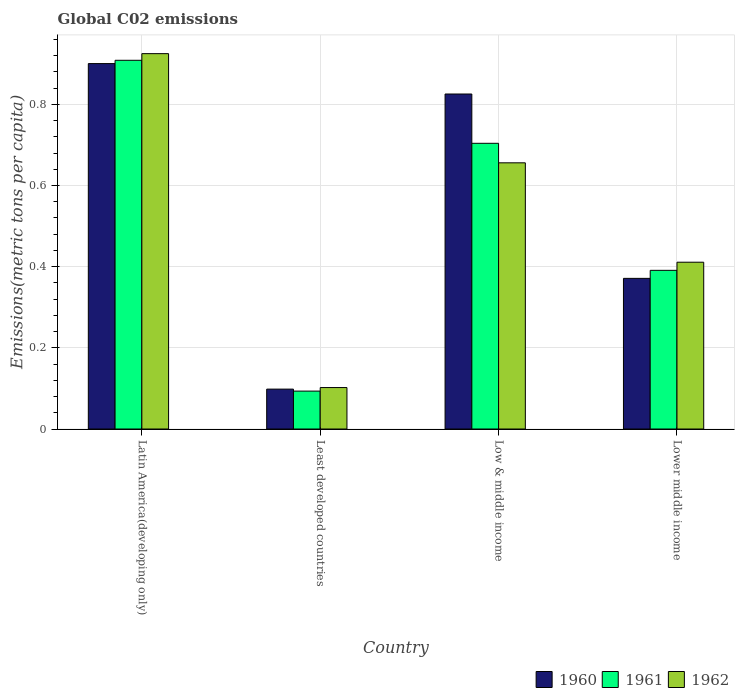How many groups of bars are there?
Your answer should be compact. 4. Are the number of bars per tick equal to the number of legend labels?
Offer a terse response. Yes. How many bars are there on the 4th tick from the left?
Your answer should be compact. 3. How many bars are there on the 2nd tick from the right?
Make the answer very short. 3. What is the label of the 3rd group of bars from the left?
Provide a short and direct response. Low & middle income. In how many cases, is the number of bars for a given country not equal to the number of legend labels?
Offer a very short reply. 0. What is the amount of CO2 emitted in in 1962 in Low & middle income?
Offer a terse response. 0.66. Across all countries, what is the maximum amount of CO2 emitted in in 1961?
Ensure brevity in your answer.  0.91. Across all countries, what is the minimum amount of CO2 emitted in in 1960?
Your answer should be compact. 0.1. In which country was the amount of CO2 emitted in in 1960 maximum?
Your answer should be compact. Latin America(developing only). In which country was the amount of CO2 emitted in in 1960 minimum?
Offer a very short reply. Least developed countries. What is the total amount of CO2 emitted in in 1961 in the graph?
Offer a very short reply. 2.1. What is the difference between the amount of CO2 emitted in in 1961 in Least developed countries and that in Low & middle income?
Your answer should be very brief. -0.61. What is the difference between the amount of CO2 emitted in in 1961 in Least developed countries and the amount of CO2 emitted in in 1960 in Lower middle income?
Offer a terse response. -0.28. What is the average amount of CO2 emitted in in 1962 per country?
Keep it short and to the point. 0.52. What is the difference between the amount of CO2 emitted in of/in 1960 and amount of CO2 emitted in of/in 1961 in Least developed countries?
Make the answer very short. 0. In how many countries, is the amount of CO2 emitted in in 1961 greater than 0.88 metric tons per capita?
Ensure brevity in your answer.  1. What is the ratio of the amount of CO2 emitted in in 1961 in Least developed countries to that in Lower middle income?
Provide a short and direct response. 0.24. Is the amount of CO2 emitted in in 1960 in Least developed countries less than that in Low & middle income?
Provide a succinct answer. Yes. Is the difference between the amount of CO2 emitted in in 1960 in Least developed countries and Lower middle income greater than the difference between the amount of CO2 emitted in in 1961 in Least developed countries and Lower middle income?
Offer a very short reply. Yes. What is the difference between the highest and the second highest amount of CO2 emitted in in 1961?
Ensure brevity in your answer.  0.2. What is the difference between the highest and the lowest amount of CO2 emitted in in 1961?
Your response must be concise. 0.82. Is the sum of the amount of CO2 emitted in in 1961 in Least developed countries and Low & middle income greater than the maximum amount of CO2 emitted in in 1960 across all countries?
Provide a succinct answer. No. Is it the case that in every country, the sum of the amount of CO2 emitted in in 1960 and amount of CO2 emitted in in 1961 is greater than the amount of CO2 emitted in in 1962?
Offer a very short reply. Yes. Are all the bars in the graph horizontal?
Your answer should be very brief. No. What is the difference between two consecutive major ticks on the Y-axis?
Make the answer very short. 0.2. Does the graph contain any zero values?
Give a very brief answer. No. Does the graph contain grids?
Your answer should be very brief. Yes. How many legend labels are there?
Offer a very short reply. 3. How are the legend labels stacked?
Ensure brevity in your answer.  Horizontal. What is the title of the graph?
Offer a very short reply. Global C02 emissions. What is the label or title of the X-axis?
Your answer should be very brief. Country. What is the label or title of the Y-axis?
Keep it short and to the point. Emissions(metric tons per capita). What is the Emissions(metric tons per capita) of 1960 in Latin America(developing only)?
Your response must be concise. 0.9. What is the Emissions(metric tons per capita) in 1961 in Latin America(developing only)?
Give a very brief answer. 0.91. What is the Emissions(metric tons per capita) in 1962 in Latin America(developing only)?
Offer a very short reply. 0.92. What is the Emissions(metric tons per capita) in 1960 in Least developed countries?
Offer a terse response. 0.1. What is the Emissions(metric tons per capita) of 1961 in Least developed countries?
Your answer should be compact. 0.09. What is the Emissions(metric tons per capita) in 1962 in Least developed countries?
Provide a short and direct response. 0.1. What is the Emissions(metric tons per capita) in 1960 in Low & middle income?
Ensure brevity in your answer.  0.83. What is the Emissions(metric tons per capita) in 1961 in Low & middle income?
Provide a short and direct response. 0.7. What is the Emissions(metric tons per capita) in 1962 in Low & middle income?
Keep it short and to the point. 0.66. What is the Emissions(metric tons per capita) of 1960 in Lower middle income?
Keep it short and to the point. 0.37. What is the Emissions(metric tons per capita) of 1961 in Lower middle income?
Your answer should be compact. 0.39. What is the Emissions(metric tons per capita) in 1962 in Lower middle income?
Ensure brevity in your answer.  0.41. Across all countries, what is the maximum Emissions(metric tons per capita) in 1960?
Provide a succinct answer. 0.9. Across all countries, what is the maximum Emissions(metric tons per capita) of 1961?
Give a very brief answer. 0.91. Across all countries, what is the maximum Emissions(metric tons per capita) of 1962?
Ensure brevity in your answer.  0.92. Across all countries, what is the minimum Emissions(metric tons per capita) of 1960?
Offer a very short reply. 0.1. Across all countries, what is the minimum Emissions(metric tons per capita) of 1961?
Give a very brief answer. 0.09. Across all countries, what is the minimum Emissions(metric tons per capita) in 1962?
Provide a short and direct response. 0.1. What is the total Emissions(metric tons per capita) in 1960 in the graph?
Provide a succinct answer. 2.2. What is the total Emissions(metric tons per capita) of 1961 in the graph?
Provide a succinct answer. 2.1. What is the total Emissions(metric tons per capita) in 1962 in the graph?
Provide a short and direct response. 2.09. What is the difference between the Emissions(metric tons per capita) in 1960 in Latin America(developing only) and that in Least developed countries?
Your response must be concise. 0.8. What is the difference between the Emissions(metric tons per capita) of 1961 in Latin America(developing only) and that in Least developed countries?
Keep it short and to the point. 0.81. What is the difference between the Emissions(metric tons per capita) in 1962 in Latin America(developing only) and that in Least developed countries?
Provide a short and direct response. 0.82. What is the difference between the Emissions(metric tons per capita) of 1960 in Latin America(developing only) and that in Low & middle income?
Keep it short and to the point. 0.07. What is the difference between the Emissions(metric tons per capita) in 1961 in Latin America(developing only) and that in Low & middle income?
Offer a terse response. 0.2. What is the difference between the Emissions(metric tons per capita) in 1962 in Latin America(developing only) and that in Low & middle income?
Keep it short and to the point. 0.27. What is the difference between the Emissions(metric tons per capita) of 1960 in Latin America(developing only) and that in Lower middle income?
Give a very brief answer. 0.53. What is the difference between the Emissions(metric tons per capita) in 1961 in Latin America(developing only) and that in Lower middle income?
Keep it short and to the point. 0.52. What is the difference between the Emissions(metric tons per capita) of 1962 in Latin America(developing only) and that in Lower middle income?
Ensure brevity in your answer.  0.51. What is the difference between the Emissions(metric tons per capita) of 1960 in Least developed countries and that in Low & middle income?
Provide a succinct answer. -0.73. What is the difference between the Emissions(metric tons per capita) of 1961 in Least developed countries and that in Low & middle income?
Keep it short and to the point. -0.61. What is the difference between the Emissions(metric tons per capita) in 1962 in Least developed countries and that in Low & middle income?
Ensure brevity in your answer.  -0.55. What is the difference between the Emissions(metric tons per capita) in 1960 in Least developed countries and that in Lower middle income?
Keep it short and to the point. -0.27. What is the difference between the Emissions(metric tons per capita) of 1961 in Least developed countries and that in Lower middle income?
Provide a succinct answer. -0.3. What is the difference between the Emissions(metric tons per capita) of 1962 in Least developed countries and that in Lower middle income?
Provide a succinct answer. -0.31. What is the difference between the Emissions(metric tons per capita) of 1960 in Low & middle income and that in Lower middle income?
Your answer should be compact. 0.45. What is the difference between the Emissions(metric tons per capita) of 1961 in Low & middle income and that in Lower middle income?
Provide a short and direct response. 0.31. What is the difference between the Emissions(metric tons per capita) of 1962 in Low & middle income and that in Lower middle income?
Keep it short and to the point. 0.24. What is the difference between the Emissions(metric tons per capita) in 1960 in Latin America(developing only) and the Emissions(metric tons per capita) in 1961 in Least developed countries?
Provide a succinct answer. 0.81. What is the difference between the Emissions(metric tons per capita) of 1960 in Latin America(developing only) and the Emissions(metric tons per capita) of 1962 in Least developed countries?
Your response must be concise. 0.8. What is the difference between the Emissions(metric tons per capita) of 1961 in Latin America(developing only) and the Emissions(metric tons per capita) of 1962 in Least developed countries?
Offer a very short reply. 0.81. What is the difference between the Emissions(metric tons per capita) of 1960 in Latin America(developing only) and the Emissions(metric tons per capita) of 1961 in Low & middle income?
Ensure brevity in your answer.  0.2. What is the difference between the Emissions(metric tons per capita) in 1960 in Latin America(developing only) and the Emissions(metric tons per capita) in 1962 in Low & middle income?
Offer a very short reply. 0.24. What is the difference between the Emissions(metric tons per capita) of 1961 in Latin America(developing only) and the Emissions(metric tons per capita) of 1962 in Low & middle income?
Give a very brief answer. 0.25. What is the difference between the Emissions(metric tons per capita) in 1960 in Latin America(developing only) and the Emissions(metric tons per capita) in 1961 in Lower middle income?
Provide a short and direct response. 0.51. What is the difference between the Emissions(metric tons per capita) in 1960 in Latin America(developing only) and the Emissions(metric tons per capita) in 1962 in Lower middle income?
Provide a succinct answer. 0.49. What is the difference between the Emissions(metric tons per capita) of 1961 in Latin America(developing only) and the Emissions(metric tons per capita) of 1962 in Lower middle income?
Keep it short and to the point. 0.5. What is the difference between the Emissions(metric tons per capita) in 1960 in Least developed countries and the Emissions(metric tons per capita) in 1961 in Low & middle income?
Your response must be concise. -0.61. What is the difference between the Emissions(metric tons per capita) of 1960 in Least developed countries and the Emissions(metric tons per capita) of 1962 in Low & middle income?
Ensure brevity in your answer.  -0.56. What is the difference between the Emissions(metric tons per capita) in 1961 in Least developed countries and the Emissions(metric tons per capita) in 1962 in Low & middle income?
Offer a very short reply. -0.56. What is the difference between the Emissions(metric tons per capita) in 1960 in Least developed countries and the Emissions(metric tons per capita) in 1961 in Lower middle income?
Keep it short and to the point. -0.29. What is the difference between the Emissions(metric tons per capita) of 1960 in Least developed countries and the Emissions(metric tons per capita) of 1962 in Lower middle income?
Your answer should be compact. -0.31. What is the difference between the Emissions(metric tons per capita) in 1961 in Least developed countries and the Emissions(metric tons per capita) in 1962 in Lower middle income?
Your answer should be compact. -0.32. What is the difference between the Emissions(metric tons per capita) of 1960 in Low & middle income and the Emissions(metric tons per capita) of 1961 in Lower middle income?
Offer a terse response. 0.43. What is the difference between the Emissions(metric tons per capita) in 1960 in Low & middle income and the Emissions(metric tons per capita) in 1962 in Lower middle income?
Your answer should be compact. 0.41. What is the difference between the Emissions(metric tons per capita) in 1961 in Low & middle income and the Emissions(metric tons per capita) in 1962 in Lower middle income?
Give a very brief answer. 0.29. What is the average Emissions(metric tons per capita) of 1960 per country?
Keep it short and to the point. 0.55. What is the average Emissions(metric tons per capita) in 1961 per country?
Your answer should be compact. 0.52. What is the average Emissions(metric tons per capita) of 1962 per country?
Your response must be concise. 0.52. What is the difference between the Emissions(metric tons per capita) in 1960 and Emissions(metric tons per capita) in 1961 in Latin America(developing only)?
Your answer should be very brief. -0.01. What is the difference between the Emissions(metric tons per capita) of 1960 and Emissions(metric tons per capita) of 1962 in Latin America(developing only)?
Your response must be concise. -0.02. What is the difference between the Emissions(metric tons per capita) in 1961 and Emissions(metric tons per capita) in 1962 in Latin America(developing only)?
Make the answer very short. -0.02. What is the difference between the Emissions(metric tons per capita) of 1960 and Emissions(metric tons per capita) of 1961 in Least developed countries?
Your answer should be very brief. 0. What is the difference between the Emissions(metric tons per capita) in 1960 and Emissions(metric tons per capita) in 1962 in Least developed countries?
Ensure brevity in your answer.  -0. What is the difference between the Emissions(metric tons per capita) in 1961 and Emissions(metric tons per capita) in 1962 in Least developed countries?
Keep it short and to the point. -0.01. What is the difference between the Emissions(metric tons per capita) in 1960 and Emissions(metric tons per capita) in 1961 in Low & middle income?
Offer a very short reply. 0.12. What is the difference between the Emissions(metric tons per capita) in 1960 and Emissions(metric tons per capita) in 1962 in Low & middle income?
Ensure brevity in your answer.  0.17. What is the difference between the Emissions(metric tons per capita) in 1961 and Emissions(metric tons per capita) in 1962 in Low & middle income?
Ensure brevity in your answer.  0.05. What is the difference between the Emissions(metric tons per capita) in 1960 and Emissions(metric tons per capita) in 1961 in Lower middle income?
Your answer should be very brief. -0.02. What is the difference between the Emissions(metric tons per capita) in 1960 and Emissions(metric tons per capita) in 1962 in Lower middle income?
Ensure brevity in your answer.  -0.04. What is the difference between the Emissions(metric tons per capita) of 1961 and Emissions(metric tons per capita) of 1962 in Lower middle income?
Provide a succinct answer. -0.02. What is the ratio of the Emissions(metric tons per capita) of 1960 in Latin America(developing only) to that in Least developed countries?
Keep it short and to the point. 9.16. What is the ratio of the Emissions(metric tons per capita) in 1961 in Latin America(developing only) to that in Least developed countries?
Offer a very short reply. 9.72. What is the ratio of the Emissions(metric tons per capita) in 1962 in Latin America(developing only) to that in Least developed countries?
Provide a short and direct response. 9.05. What is the ratio of the Emissions(metric tons per capita) of 1960 in Latin America(developing only) to that in Low & middle income?
Make the answer very short. 1.09. What is the ratio of the Emissions(metric tons per capita) of 1961 in Latin America(developing only) to that in Low & middle income?
Give a very brief answer. 1.29. What is the ratio of the Emissions(metric tons per capita) in 1962 in Latin America(developing only) to that in Low & middle income?
Your response must be concise. 1.41. What is the ratio of the Emissions(metric tons per capita) in 1960 in Latin America(developing only) to that in Lower middle income?
Your answer should be compact. 2.43. What is the ratio of the Emissions(metric tons per capita) in 1961 in Latin America(developing only) to that in Lower middle income?
Your answer should be compact. 2.32. What is the ratio of the Emissions(metric tons per capita) of 1962 in Latin America(developing only) to that in Lower middle income?
Your answer should be very brief. 2.25. What is the ratio of the Emissions(metric tons per capita) of 1960 in Least developed countries to that in Low & middle income?
Make the answer very short. 0.12. What is the ratio of the Emissions(metric tons per capita) in 1961 in Least developed countries to that in Low & middle income?
Your response must be concise. 0.13. What is the ratio of the Emissions(metric tons per capita) in 1962 in Least developed countries to that in Low & middle income?
Your response must be concise. 0.16. What is the ratio of the Emissions(metric tons per capita) in 1960 in Least developed countries to that in Lower middle income?
Give a very brief answer. 0.26. What is the ratio of the Emissions(metric tons per capita) in 1961 in Least developed countries to that in Lower middle income?
Keep it short and to the point. 0.24. What is the ratio of the Emissions(metric tons per capita) in 1962 in Least developed countries to that in Lower middle income?
Offer a terse response. 0.25. What is the ratio of the Emissions(metric tons per capita) of 1960 in Low & middle income to that in Lower middle income?
Offer a terse response. 2.22. What is the ratio of the Emissions(metric tons per capita) of 1961 in Low & middle income to that in Lower middle income?
Your answer should be compact. 1.8. What is the ratio of the Emissions(metric tons per capita) of 1962 in Low & middle income to that in Lower middle income?
Ensure brevity in your answer.  1.6. What is the difference between the highest and the second highest Emissions(metric tons per capita) in 1960?
Offer a very short reply. 0.07. What is the difference between the highest and the second highest Emissions(metric tons per capita) of 1961?
Offer a terse response. 0.2. What is the difference between the highest and the second highest Emissions(metric tons per capita) in 1962?
Give a very brief answer. 0.27. What is the difference between the highest and the lowest Emissions(metric tons per capita) in 1960?
Offer a terse response. 0.8. What is the difference between the highest and the lowest Emissions(metric tons per capita) in 1961?
Your answer should be very brief. 0.81. What is the difference between the highest and the lowest Emissions(metric tons per capita) in 1962?
Offer a terse response. 0.82. 